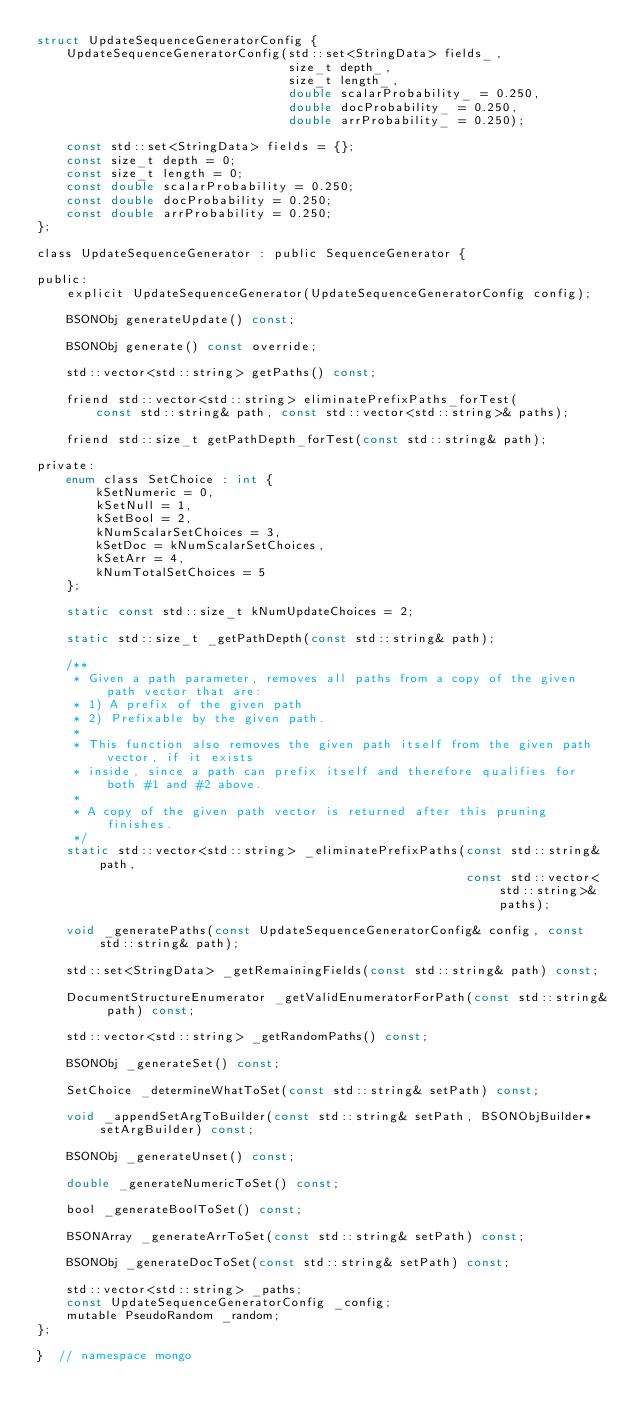Convert code to text. <code><loc_0><loc_0><loc_500><loc_500><_C_>struct UpdateSequenceGeneratorConfig {
    UpdateSequenceGeneratorConfig(std::set<StringData> fields_,
                                  size_t depth_,
                                  size_t length_,
                                  double scalarProbability_ = 0.250,
                                  double docProbability_ = 0.250,
                                  double arrProbability_ = 0.250);

    const std::set<StringData> fields = {};
    const size_t depth = 0;
    const size_t length = 0;
    const double scalarProbability = 0.250;
    const double docProbability = 0.250;
    const double arrProbability = 0.250;
};

class UpdateSequenceGenerator : public SequenceGenerator {

public:
    explicit UpdateSequenceGenerator(UpdateSequenceGeneratorConfig config);

    BSONObj generateUpdate() const;

    BSONObj generate() const override;

    std::vector<std::string> getPaths() const;

    friend std::vector<std::string> eliminatePrefixPaths_forTest(
        const std::string& path, const std::vector<std::string>& paths);

    friend std::size_t getPathDepth_forTest(const std::string& path);

private:
    enum class SetChoice : int {
        kSetNumeric = 0,
        kSetNull = 1,
        kSetBool = 2,
        kNumScalarSetChoices = 3,
        kSetDoc = kNumScalarSetChoices,
        kSetArr = 4,
        kNumTotalSetChoices = 5
    };

    static const std::size_t kNumUpdateChoices = 2;

    static std::size_t _getPathDepth(const std::string& path);

    /**
     * Given a path parameter, removes all paths from a copy of the given path vector that are:
     * 1) A prefix of the given path
     * 2) Prefixable by the given path.
     *
     * This function also removes the given path itself from the given path vector, if it exists
     * inside, since a path can prefix itself and therefore qualifies for both #1 and #2 above.
     *
     * A copy of the given path vector is returned after this pruning finishes.
     */
    static std::vector<std::string> _eliminatePrefixPaths(const std::string& path,
                                                          const std::vector<std::string>& paths);

    void _generatePaths(const UpdateSequenceGeneratorConfig& config, const std::string& path);

    std::set<StringData> _getRemainingFields(const std::string& path) const;

    DocumentStructureEnumerator _getValidEnumeratorForPath(const std::string& path) const;

    std::vector<std::string> _getRandomPaths() const;

    BSONObj _generateSet() const;

    SetChoice _determineWhatToSet(const std::string& setPath) const;

    void _appendSetArgToBuilder(const std::string& setPath, BSONObjBuilder* setArgBuilder) const;

    BSONObj _generateUnset() const;

    double _generateNumericToSet() const;

    bool _generateBoolToSet() const;

    BSONArray _generateArrToSet(const std::string& setPath) const;

    BSONObj _generateDocToSet(const std::string& setPath) const;

    std::vector<std::string> _paths;
    const UpdateSequenceGeneratorConfig _config;
    mutable PseudoRandom _random;
};

}  // namespace mongo
</code> 